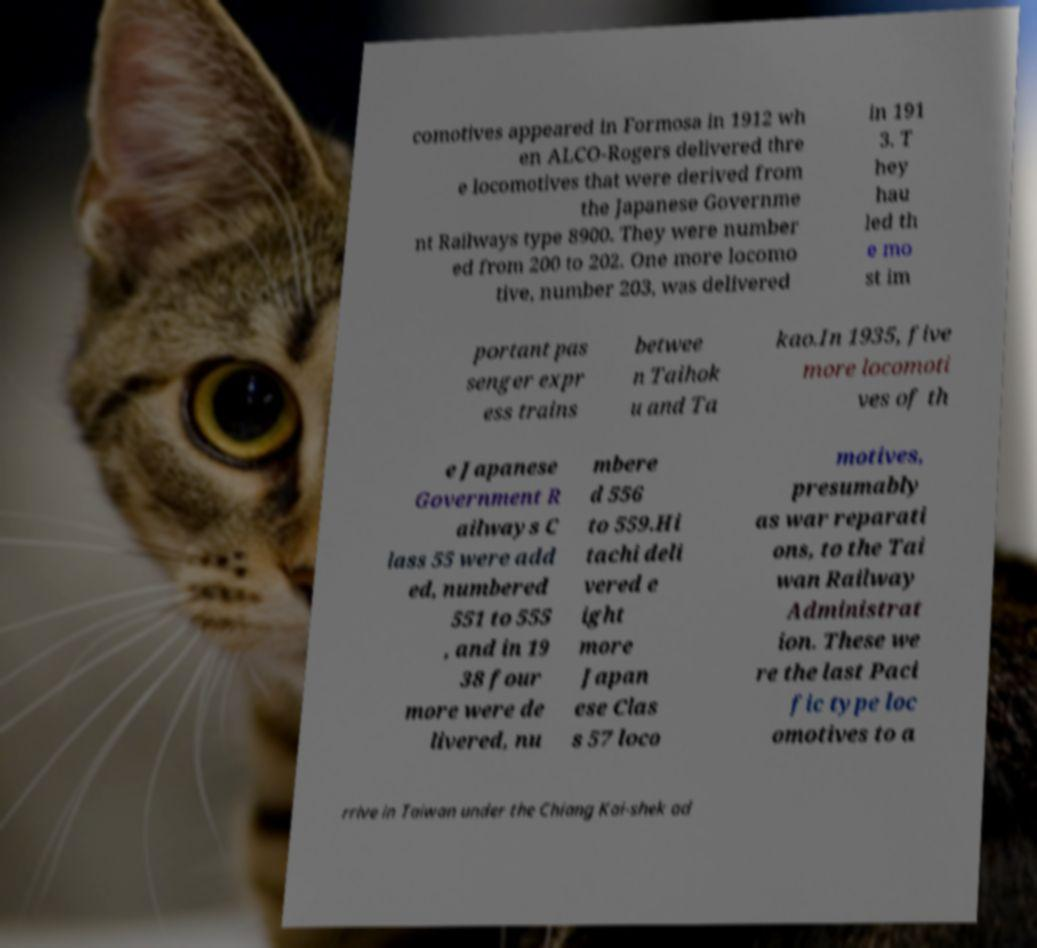I need the written content from this picture converted into text. Can you do that? comotives appeared in Formosa in 1912 wh en ALCO-Rogers delivered thre e locomotives that were derived from the Japanese Governme nt Railways type 8900. They were number ed from 200 to 202. One more locomo tive, number 203, was delivered in 191 3. T hey hau led th e mo st im portant pas senger expr ess trains betwee n Taihok u and Ta kao.In 1935, five more locomoti ves of th e Japanese Government R ailways C lass 55 were add ed, numbered 551 to 555 , and in 19 38 four more were de livered, nu mbere d 556 to 559.Hi tachi deli vered e ight more Japan ese Clas s 57 loco motives, presumably as war reparati ons, to the Tai wan Railway Administrat ion. These we re the last Paci fic type loc omotives to a rrive in Taiwan under the Chiang Kai-shek ad 